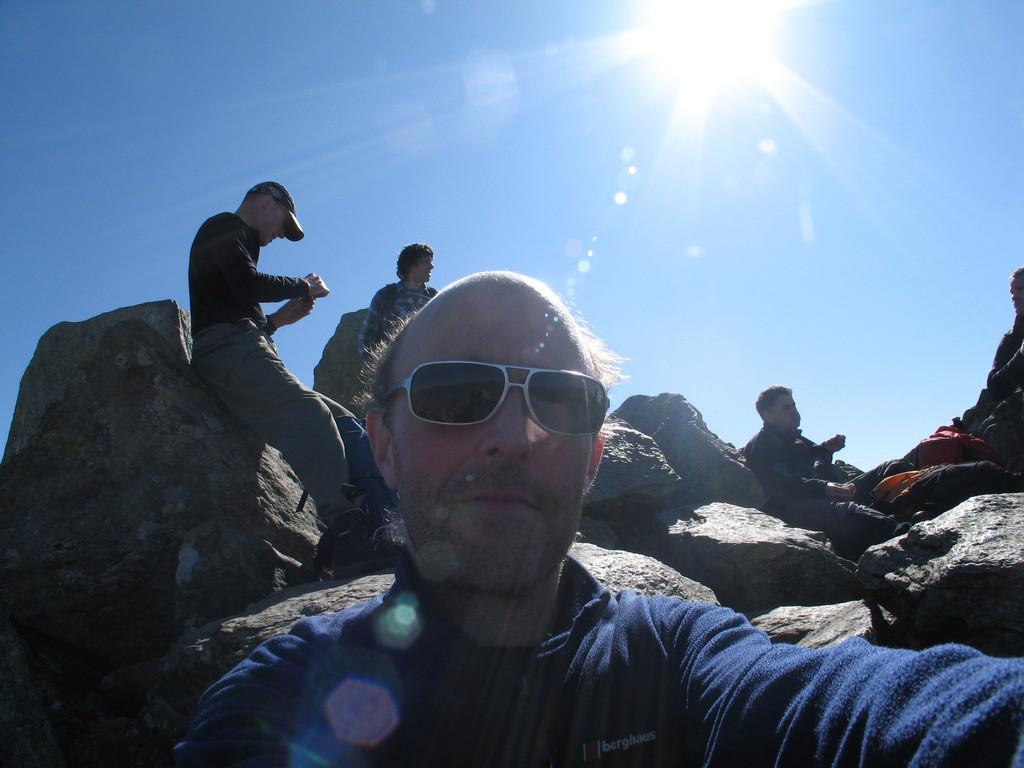How would you summarize this image in a sentence or two? In the foreground of the image we can see a person where he wore a blue color shirt and black specks. In the middle of the image we can see some persons are sitting on the rocks and making conversation between them. On the top of the image we can see the sky and the sun. 